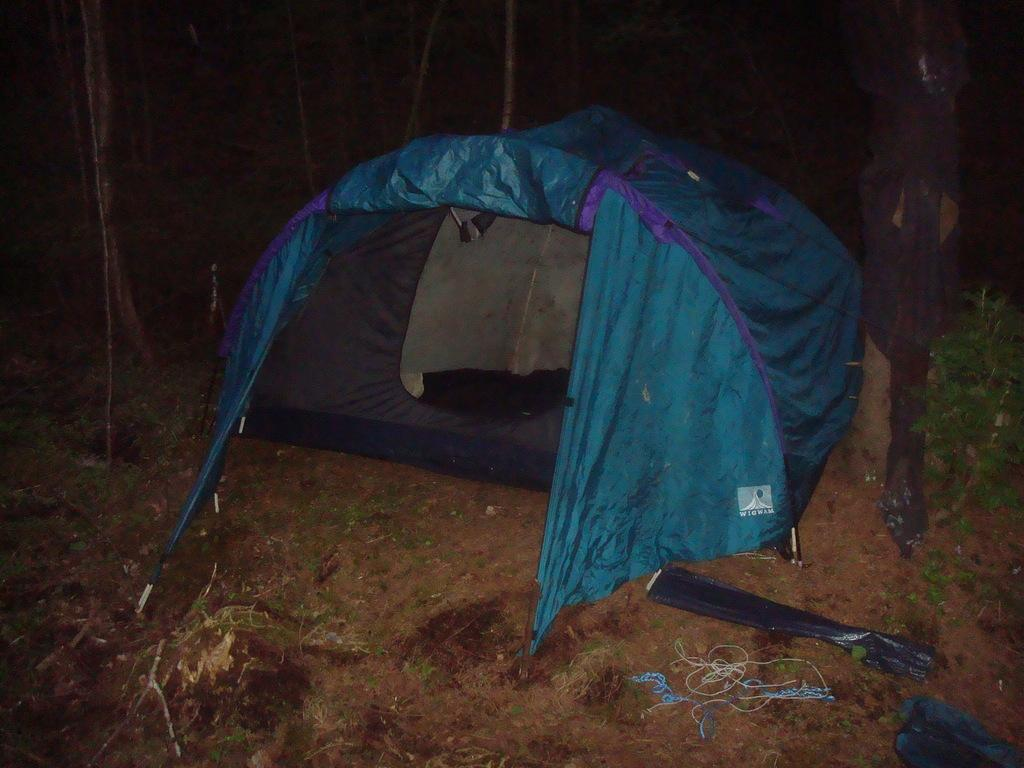What type of objects can be seen in the image? There are stems in the image. What structure is located in the middle of the image? There is a tent in the middle of the image. What type of vegetation is on the right side of the image? There is a plant on the right side of the image. What type of pollution can be seen in the image? There is no pollution present in the image. Is there a pig visible in the image? There is no pig present in the image. 